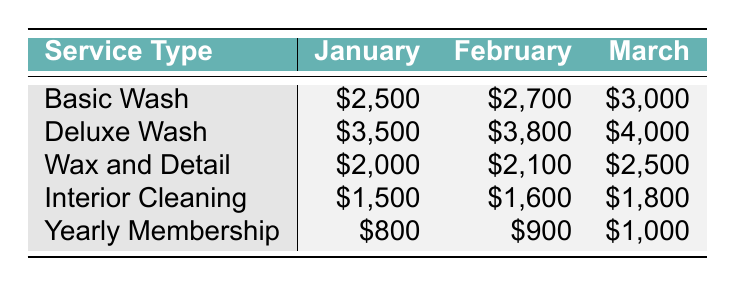What was the revenue from Basic Wash in February? The table shows that the revenue for Basic Wash in February is listed directly under the February column for Basic Wash, which is $2,700.
Answer: $2,700 Which service generated the highest revenue in March? By inspecting the March column for each service type, Deluxe Wash shows the highest revenue at $4,000, compared to the other services.
Answer: Deluxe Wash What is the total revenue from Interior Cleaning for Q1 2023? To find the total revenue from Interior Cleaning, we add the values for January, February, and March: $1,500 + $1,600 + $1,800 = $4,900.
Answer: $4,900 Did the revenue from Yearly Membership increase every month in Q1 2023? Looking at the Yearly Membership row, the revenues are $800 in January, $900 in February, and $1,000 in March. Since all the values are increasing, the answer is yes.
Answer: Yes What is the average revenue for Deluxe Wash for Q1 2023? To find the average revenue for Deluxe Wash, add the monthly revenues: $3,500 + $3,800 + $4,000 = $11,300, then divide by 3 (the number of months), which gives $11,300 / 3 = $3,766.67.
Answer: $3,766.67 Which service's revenue increased the most from January to March? We can calculate the change in revenue for each service from January to March: Basic Wash ($3,000 - $2,500 = $500), Deluxe Wash ($4,000 - $3,500 = $500), Wax and Detail ($2,500 - $2,000 = $500), Interior Cleaning ($1,800 - $1,500 = $300), and Yearly Membership ($1,000 - $800 = $200). The max increase is $500 for both Basic Wash and Deluxe Wash.
Answer: Basic Wash and Deluxe Wash How much more did Deluxe Wash earn than Wax and Detail in February? The revenue for Deluxe Wash in February is $3,800 and for Wax and Detail, it is $2,100. Subtracting gives $3,800 - $2,100 = $1,700.
Answer: $1,700 What was the total revenue for all services in January? We sum up the revenues for all services for January: $2,500 + $3,500 + $2,000 + $1,500 + $800 = $10,300.
Answer: $10,300 